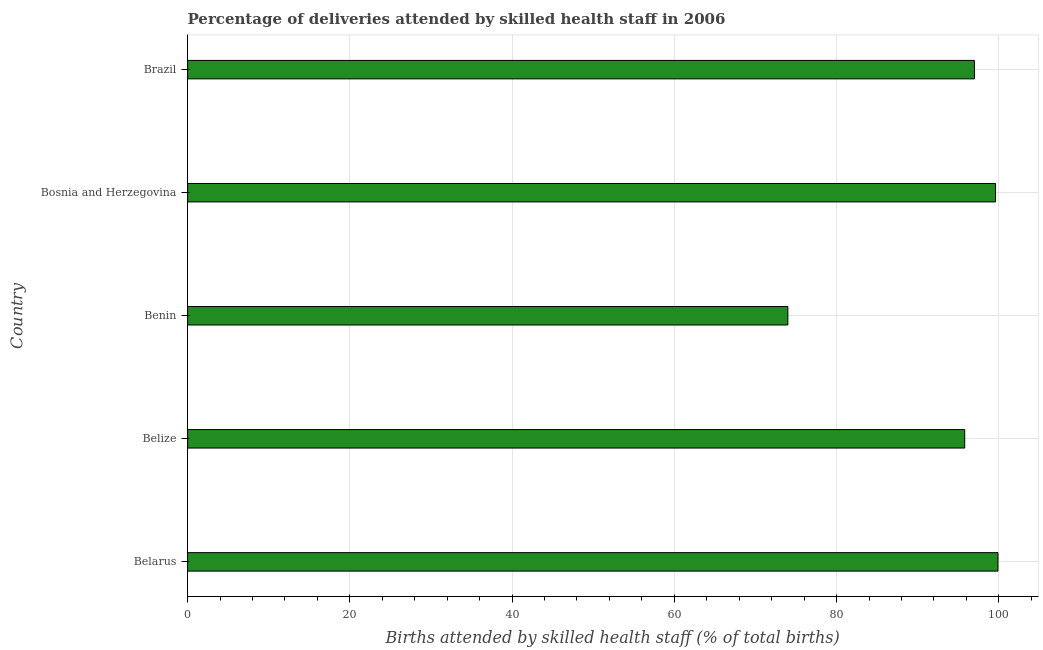What is the title of the graph?
Your answer should be compact. Percentage of deliveries attended by skilled health staff in 2006. What is the label or title of the X-axis?
Offer a terse response. Births attended by skilled health staff (% of total births). What is the number of births attended by skilled health staff in Bosnia and Herzegovina?
Ensure brevity in your answer.  99.6. Across all countries, what is the maximum number of births attended by skilled health staff?
Give a very brief answer. 99.9. In which country was the number of births attended by skilled health staff maximum?
Your response must be concise. Belarus. In which country was the number of births attended by skilled health staff minimum?
Provide a short and direct response. Benin. What is the sum of the number of births attended by skilled health staff?
Offer a very short reply. 466.3. What is the average number of births attended by skilled health staff per country?
Make the answer very short. 93.26. What is the median number of births attended by skilled health staff?
Make the answer very short. 97. In how many countries, is the number of births attended by skilled health staff greater than 56 %?
Offer a terse response. 5. What is the ratio of the number of births attended by skilled health staff in Belarus to that in Benin?
Ensure brevity in your answer.  1.35. What is the difference between the highest and the lowest number of births attended by skilled health staff?
Keep it short and to the point. 25.9. How many bars are there?
Provide a short and direct response. 5. Are all the bars in the graph horizontal?
Offer a terse response. Yes. How many countries are there in the graph?
Ensure brevity in your answer.  5. What is the Births attended by skilled health staff (% of total births) of Belarus?
Your response must be concise. 99.9. What is the Births attended by skilled health staff (% of total births) of Belize?
Your response must be concise. 95.8. What is the Births attended by skilled health staff (% of total births) in Benin?
Offer a terse response. 74. What is the Births attended by skilled health staff (% of total births) of Bosnia and Herzegovina?
Offer a very short reply. 99.6. What is the Births attended by skilled health staff (% of total births) of Brazil?
Your answer should be compact. 97. What is the difference between the Births attended by skilled health staff (% of total births) in Belarus and Belize?
Offer a terse response. 4.1. What is the difference between the Births attended by skilled health staff (% of total births) in Belarus and Benin?
Provide a short and direct response. 25.9. What is the difference between the Births attended by skilled health staff (% of total births) in Belarus and Bosnia and Herzegovina?
Keep it short and to the point. 0.3. What is the difference between the Births attended by skilled health staff (% of total births) in Belarus and Brazil?
Provide a succinct answer. 2.9. What is the difference between the Births attended by skilled health staff (% of total births) in Belize and Benin?
Give a very brief answer. 21.8. What is the difference between the Births attended by skilled health staff (% of total births) in Belize and Bosnia and Herzegovina?
Provide a succinct answer. -3.8. What is the difference between the Births attended by skilled health staff (% of total births) in Belize and Brazil?
Keep it short and to the point. -1.2. What is the difference between the Births attended by skilled health staff (% of total births) in Benin and Bosnia and Herzegovina?
Your response must be concise. -25.6. What is the ratio of the Births attended by skilled health staff (% of total births) in Belarus to that in Belize?
Your response must be concise. 1.04. What is the ratio of the Births attended by skilled health staff (% of total births) in Belarus to that in Benin?
Your answer should be very brief. 1.35. What is the ratio of the Births attended by skilled health staff (% of total births) in Belarus to that in Brazil?
Make the answer very short. 1.03. What is the ratio of the Births attended by skilled health staff (% of total births) in Belize to that in Benin?
Your answer should be very brief. 1.29. What is the ratio of the Births attended by skilled health staff (% of total births) in Belize to that in Bosnia and Herzegovina?
Ensure brevity in your answer.  0.96. What is the ratio of the Births attended by skilled health staff (% of total births) in Benin to that in Bosnia and Herzegovina?
Keep it short and to the point. 0.74. What is the ratio of the Births attended by skilled health staff (% of total births) in Benin to that in Brazil?
Offer a very short reply. 0.76. 